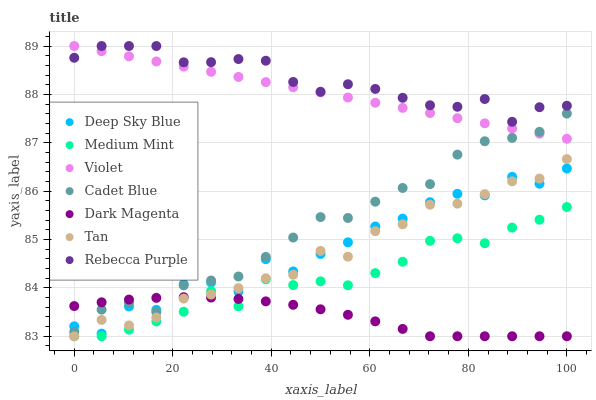Does Dark Magenta have the minimum area under the curve?
Answer yes or no. Yes. Does Rebecca Purple have the maximum area under the curve?
Answer yes or no. Yes. Does Cadet Blue have the minimum area under the curve?
Answer yes or no. No. Does Cadet Blue have the maximum area under the curve?
Answer yes or no. No. Is Violet the smoothest?
Answer yes or no. Yes. Is Deep Sky Blue the roughest?
Answer yes or no. Yes. Is Cadet Blue the smoothest?
Answer yes or no. No. Is Cadet Blue the roughest?
Answer yes or no. No. Does Medium Mint have the lowest value?
Answer yes or no. Yes. Does Cadet Blue have the lowest value?
Answer yes or no. No. Does Violet have the highest value?
Answer yes or no. Yes. Does Cadet Blue have the highest value?
Answer yes or no. No. Is Tan less than Cadet Blue?
Answer yes or no. Yes. Is Deep Sky Blue greater than Medium Mint?
Answer yes or no. Yes. Does Rebecca Purple intersect Violet?
Answer yes or no. Yes. Is Rebecca Purple less than Violet?
Answer yes or no. No. Is Rebecca Purple greater than Violet?
Answer yes or no. No. Does Tan intersect Cadet Blue?
Answer yes or no. No. 